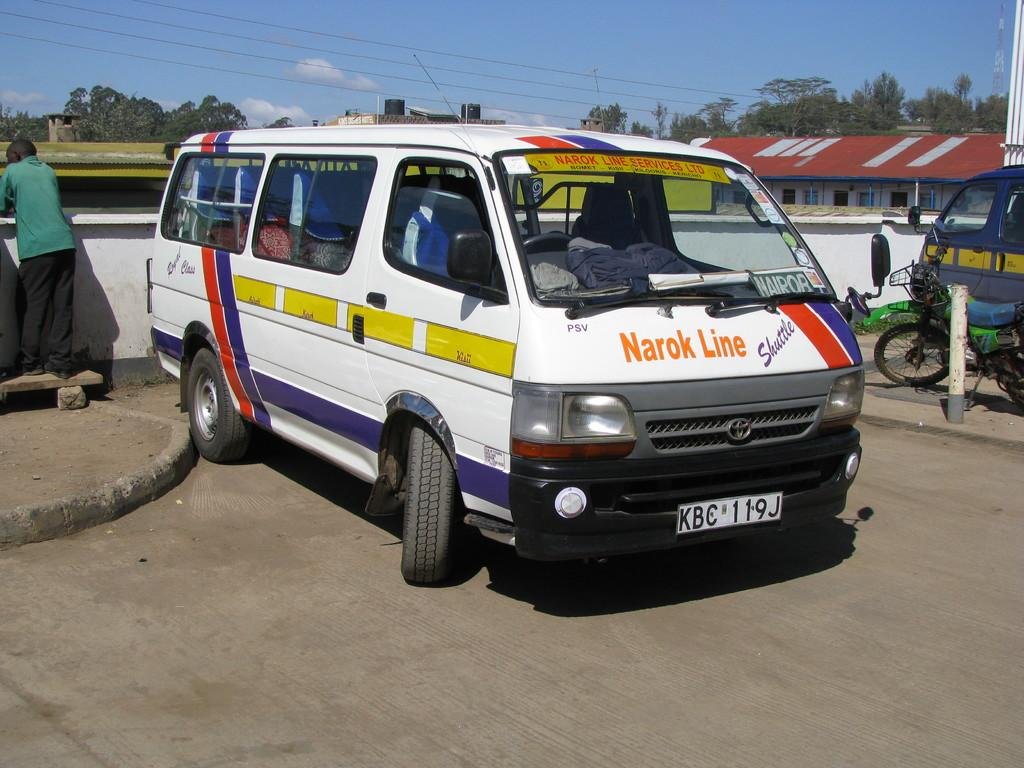<image>
Give a short and clear explanation of the subsequent image. A man in a green shirt is standing behind a van from the Narok Line 